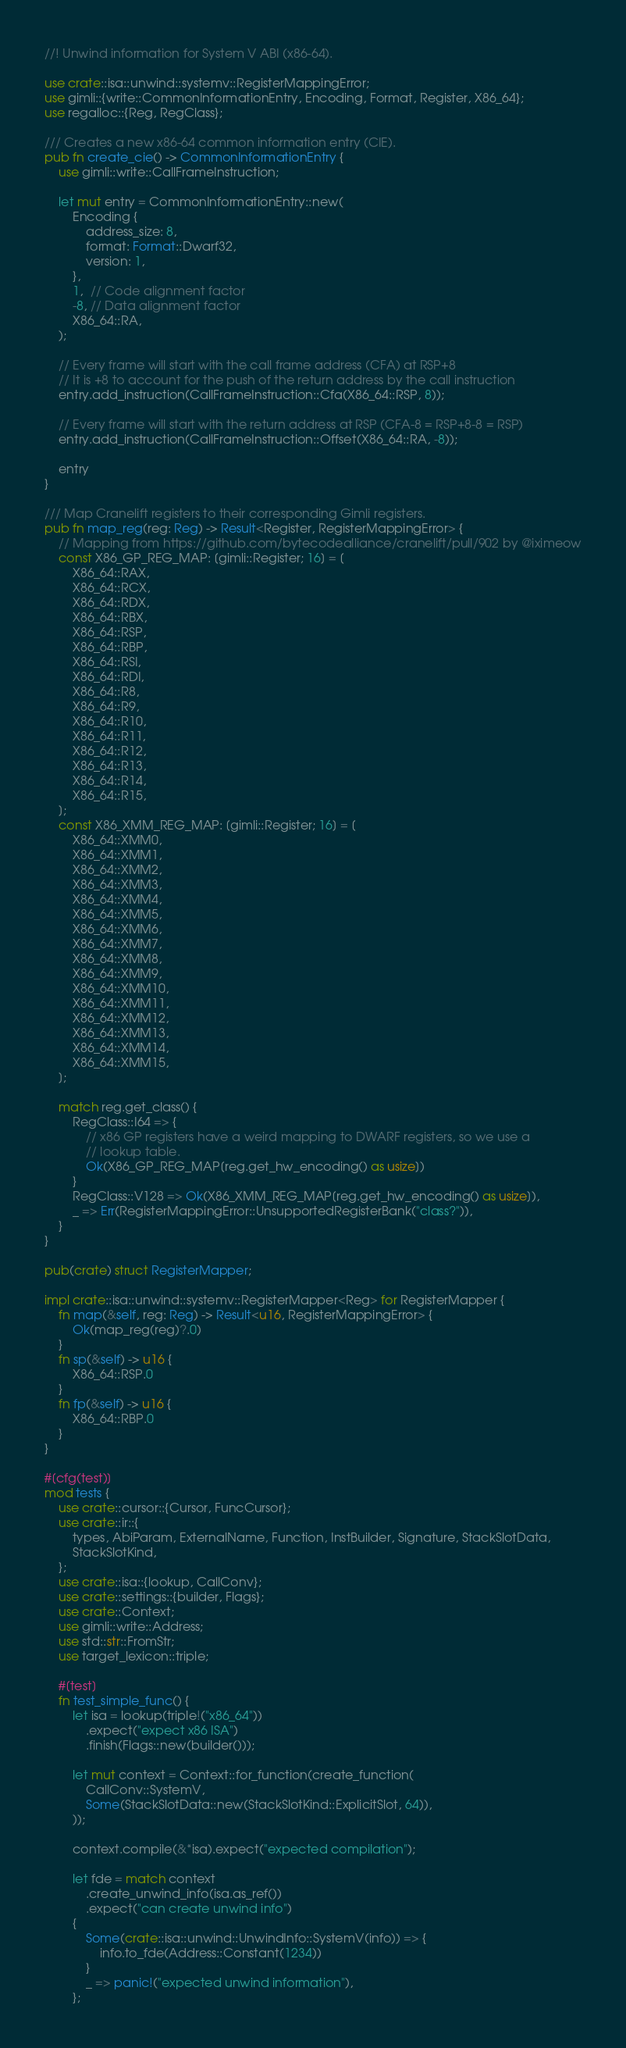<code> <loc_0><loc_0><loc_500><loc_500><_Rust_>//! Unwind information for System V ABI (x86-64).

use crate::isa::unwind::systemv::RegisterMappingError;
use gimli::{write::CommonInformationEntry, Encoding, Format, Register, X86_64};
use regalloc::{Reg, RegClass};

/// Creates a new x86-64 common information entry (CIE).
pub fn create_cie() -> CommonInformationEntry {
    use gimli::write::CallFrameInstruction;

    let mut entry = CommonInformationEntry::new(
        Encoding {
            address_size: 8,
            format: Format::Dwarf32,
            version: 1,
        },
        1,  // Code alignment factor
        -8, // Data alignment factor
        X86_64::RA,
    );

    // Every frame will start with the call frame address (CFA) at RSP+8
    // It is +8 to account for the push of the return address by the call instruction
    entry.add_instruction(CallFrameInstruction::Cfa(X86_64::RSP, 8));

    // Every frame will start with the return address at RSP (CFA-8 = RSP+8-8 = RSP)
    entry.add_instruction(CallFrameInstruction::Offset(X86_64::RA, -8));

    entry
}

/// Map Cranelift registers to their corresponding Gimli registers.
pub fn map_reg(reg: Reg) -> Result<Register, RegisterMappingError> {
    // Mapping from https://github.com/bytecodealliance/cranelift/pull/902 by @iximeow
    const X86_GP_REG_MAP: [gimli::Register; 16] = [
        X86_64::RAX,
        X86_64::RCX,
        X86_64::RDX,
        X86_64::RBX,
        X86_64::RSP,
        X86_64::RBP,
        X86_64::RSI,
        X86_64::RDI,
        X86_64::R8,
        X86_64::R9,
        X86_64::R10,
        X86_64::R11,
        X86_64::R12,
        X86_64::R13,
        X86_64::R14,
        X86_64::R15,
    ];
    const X86_XMM_REG_MAP: [gimli::Register; 16] = [
        X86_64::XMM0,
        X86_64::XMM1,
        X86_64::XMM2,
        X86_64::XMM3,
        X86_64::XMM4,
        X86_64::XMM5,
        X86_64::XMM6,
        X86_64::XMM7,
        X86_64::XMM8,
        X86_64::XMM9,
        X86_64::XMM10,
        X86_64::XMM11,
        X86_64::XMM12,
        X86_64::XMM13,
        X86_64::XMM14,
        X86_64::XMM15,
    ];

    match reg.get_class() {
        RegClass::I64 => {
            // x86 GP registers have a weird mapping to DWARF registers, so we use a
            // lookup table.
            Ok(X86_GP_REG_MAP[reg.get_hw_encoding() as usize])
        }
        RegClass::V128 => Ok(X86_XMM_REG_MAP[reg.get_hw_encoding() as usize]),
        _ => Err(RegisterMappingError::UnsupportedRegisterBank("class?")),
    }
}

pub(crate) struct RegisterMapper;

impl crate::isa::unwind::systemv::RegisterMapper<Reg> for RegisterMapper {
    fn map(&self, reg: Reg) -> Result<u16, RegisterMappingError> {
        Ok(map_reg(reg)?.0)
    }
    fn sp(&self) -> u16 {
        X86_64::RSP.0
    }
    fn fp(&self) -> u16 {
        X86_64::RBP.0
    }
}

#[cfg(test)]
mod tests {
    use crate::cursor::{Cursor, FuncCursor};
    use crate::ir::{
        types, AbiParam, ExternalName, Function, InstBuilder, Signature, StackSlotData,
        StackSlotKind,
    };
    use crate::isa::{lookup, CallConv};
    use crate::settings::{builder, Flags};
    use crate::Context;
    use gimli::write::Address;
    use std::str::FromStr;
    use target_lexicon::triple;

    #[test]
    fn test_simple_func() {
        let isa = lookup(triple!("x86_64"))
            .expect("expect x86 ISA")
            .finish(Flags::new(builder()));

        let mut context = Context::for_function(create_function(
            CallConv::SystemV,
            Some(StackSlotData::new(StackSlotKind::ExplicitSlot, 64)),
        ));

        context.compile(&*isa).expect("expected compilation");

        let fde = match context
            .create_unwind_info(isa.as_ref())
            .expect("can create unwind info")
        {
            Some(crate::isa::unwind::UnwindInfo::SystemV(info)) => {
                info.to_fde(Address::Constant(1234))
            }
            _ => panic!("expected unwind information"),
        };
</code> 